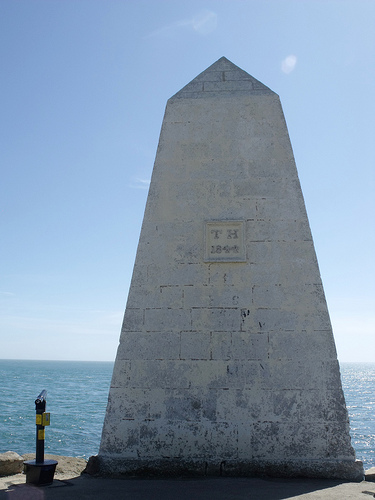<image>
Can you confirm if the sky is behind the wall? Yes. From this viewpoint, the sky is positioned behind the wall, with the wall partially or fully occluding the sky. Is the sky behind the water? No. The sky is not behind the water. From this viewpoint, the sky appears to be positioned elsewhere in the scene. 